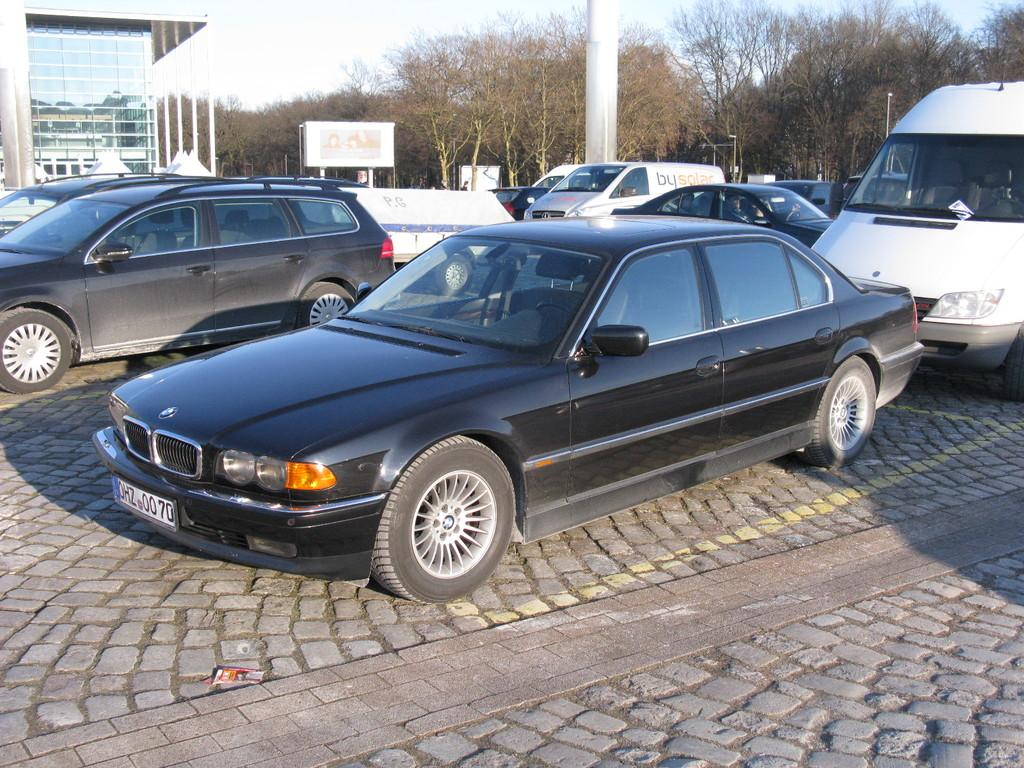What can be seen in the foreground of the image? There are fleets of cars and vehicles on the road in the foreground. What is visible in the background of the image? There are trees, buildings, a fence, and the sky in the background. Can you describe the time of day when the image was taken? The image was taken during the day. What type of sweater is the goose wearing in the image? There is no goose or sweater present in the image. How does the air affect the movement of the cars in the image? The image does not provide information about the air or its effect on the movement of the cars. 